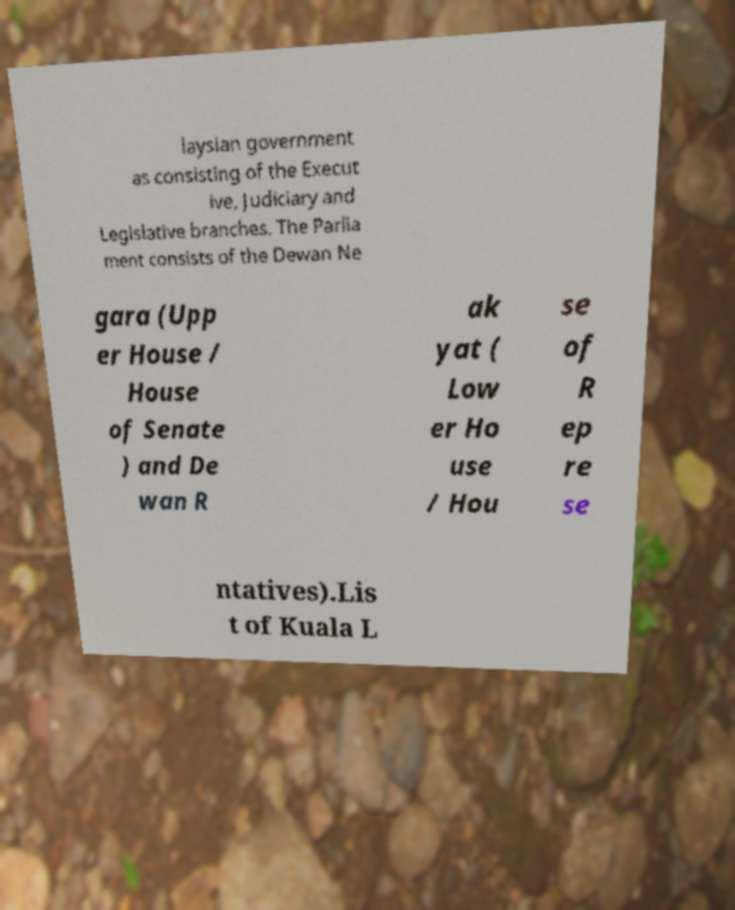There's text embedded in this image that I need extracted. Can you transcribe it verbatim? laysian government as consisting of the Execut ive, Judiciary and Legislative branches. The Parlia ment consists of the Dewan Ne gara (Upp er House / House of Senate ) and De wan R ak yat ( Low er Ho use / Hou se of R ep re se ntatives).Lis t of Kuala L 